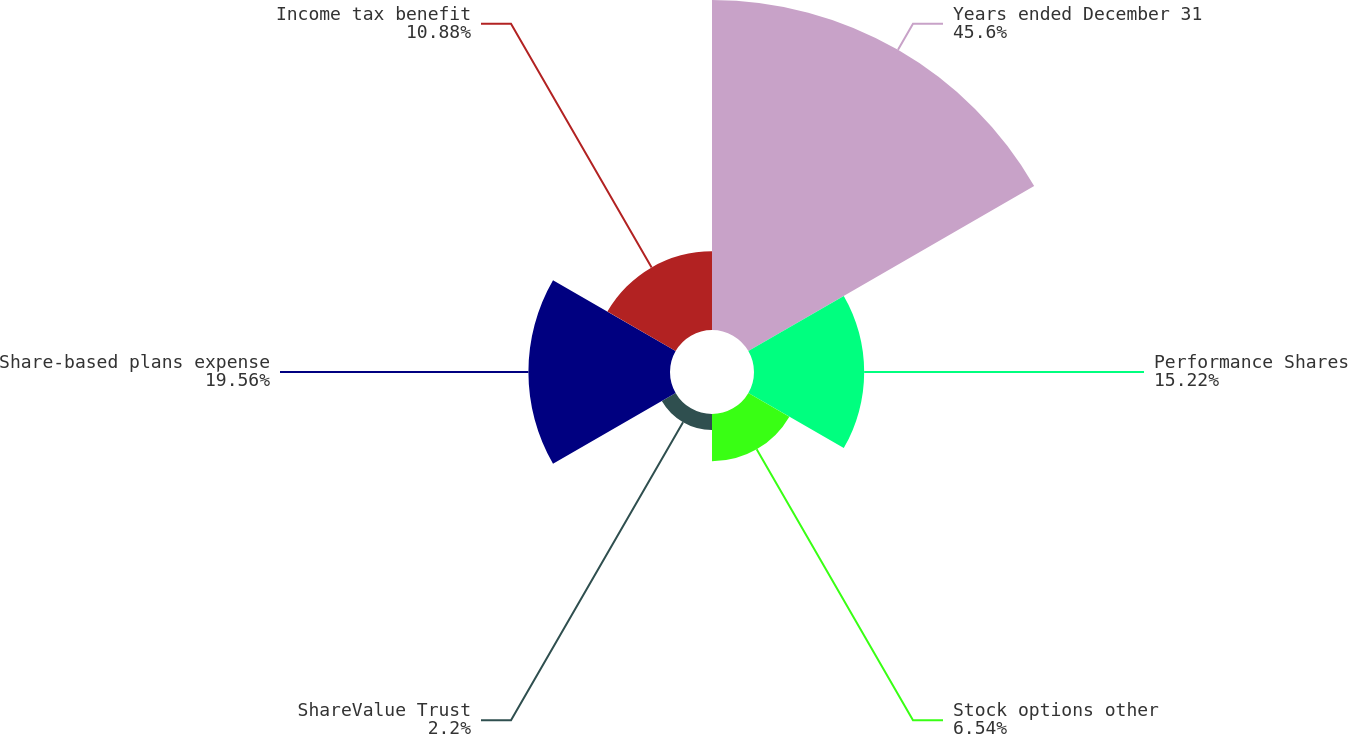Convert chart. <chart><loc_0><loc_0><loc_500><loc_500><pie_chart><fcel>Years ended December 31<fcel>Performance Shares<fcel>Stock options other<fcel>ShareValue Trust<fcel>Share-based plans expense<fcel>Income tax benefit<nl><fcel>45.59%<fcel>15.22%<fcel>6.54%<fcel>2.2%<fcel>19.56%<fcel>10.88%<nl></chart> 